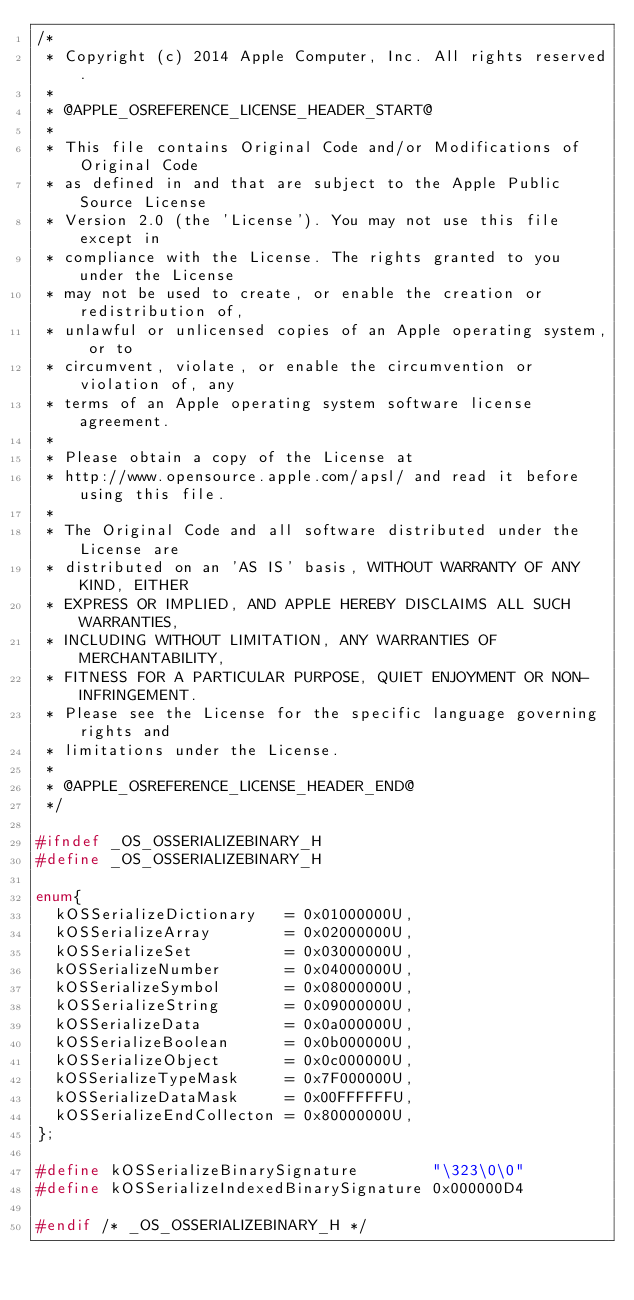Convert code to text. <code><loc_0><loc_0><loc_500><loc_500><_C_>/*
 * Copyright (c) 2014 Apple Computer, Inc. All rights reserved.
 *
 * @APPLE_OSREFERENCE_LICENSE_HEADER_START@
 *
 * This file contains Original Code and/or Modifications of Original Code
 * as defined in and that are subject to the Apple Public Source License
 * Version 2.0 (the 'License'). You may not use this file except in
 * compliance with the License. The rights granted to you under the License
 * may not be used to create, or enable the creation or redistribution of,
 * unlawful or unlicensed copies of an Apple operating system, or to
 * circumvent, violate, or enable the circumvention or violation of, any
 * terms of an Apple operating system software license agreement.
 *
 * Please obtain a copy of the License at
 * http://www.opensource.apple.com/apsl/ and read it before using this file.
 *
 * The Original Code and all software distributed under the License are
 * distributed on an 'AS IS' basis, WITHOUT WARRANTY OF ANY KIND, EITHER
 * EXPRESS OR IMPLIED, AND APPLE HEREBY DISCLAIMS ALL SUCH WARRANTIES,
 * INCLUDING WITHOUT LIMITATION, ANY WARRANTIES OF MERCHANTABILITY,
 * FITNESS FOR A PARTICULAR PURPOSE, QUIET ENJOYMENT OR NON-INFRINGEMENT.
 * Please see the License for the specific language governing rights and
 * limitations under the License.
 *
 * @APPLE_OSREFERENCE_LICENSE_HEADER_END@
 */

#ifndef _OS_OSSERIALIZEBINARY_H
#define _OS_OSSERIALIZEBINARY_H

enum{
	kOSSerializeDictionary   = 0x01000000U,
	kOSSerializeArray        = 0x02000000U,
	kOSSerializeSet          = 0x03000000U,
	kOSSerializeNumber       = 0x04000000U,
	kOSSerializeSymbol       = 0x08000000U,
	kOSSerializeString       = 0x09000000U,
	kOSSerializeData         = 0x0a000000U,
	kOSSerializeBoolean      = 0x0b000000U,
	kOSSerializeObject       = 0x0c000000U,
	kOSSerializeTypeMask     = 0x7F000000U,
	kOSSerializeDataMask     = 0x00FFFFFFU,
	kOSSerializeEndCollecton = 0x80000000U,
};

#define kOSSerializeBinarySignature        "\323\0\0"
#define kOSSerializeIndexedBinarySignature 0x000000D4

#endif /* _OS_OSSERIALIZEBINARY_H */
</code> 